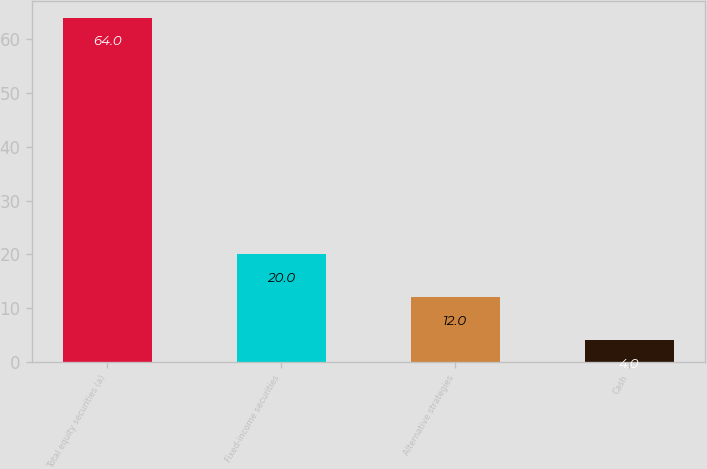Convert chart. <chart><loc_0><loc_0><loc_500><loc_500><bar_chart><fcel>Total equity securities (a)<fcel>Fixed-income securities<fcel>Alternative strategies<fcel>Cash<nl><fcel>64<fcel>20<fcel>12<fcel>4<nl></chart> 